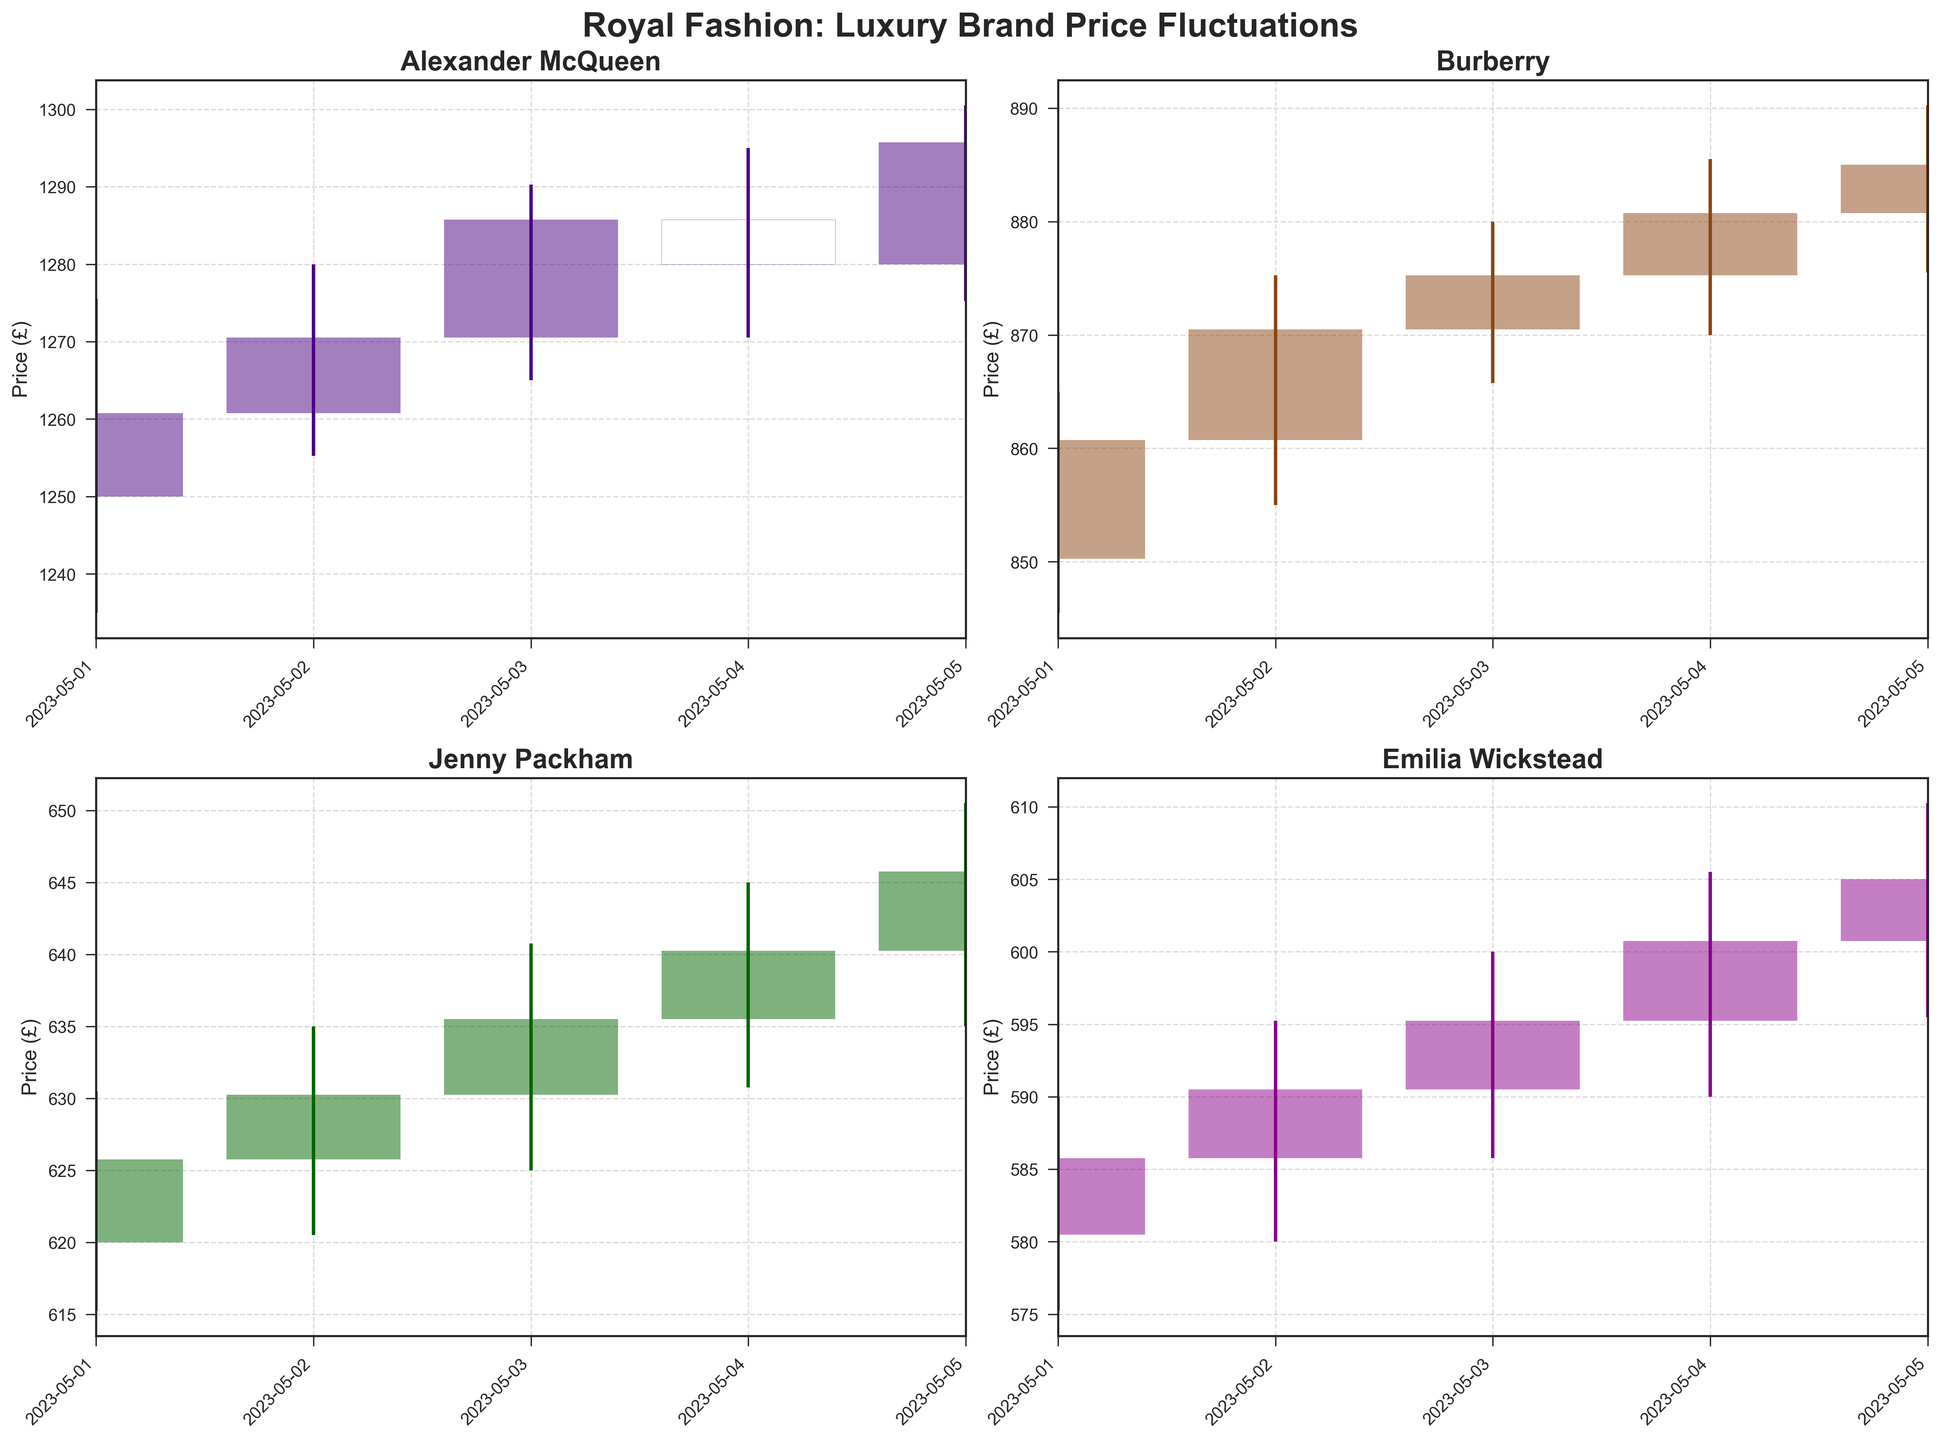What is the highest closing price for Alexander McQueen during the time period shown? The plot for Alexander McQueen displays daily price data, including closing prices. Identify the highest point on the closing price axis for Alexander McQueen.
Answer: 1295.75 Which brand had the lowest closing price on May 1, 2023? Look at the closing prices for each brand on May 1 in their respective subplots. Compare these values to determine the lowest one.
Answer: Emilia Wickstead How do the closing prices of Burberry and Jenny Packham compare on May 3, 2023? Check the Burberry and Jenny Packham subplots for May 3. Identify and compare the closing prices.
Answer: Burberry closed higher What is the average closing price of Emilia Wickstead over the five days shown? Sum the closing prices of Emilia Wickstead (585.75, 590.50, 595.25, 600.75, 605.00) and divide by the number of days (5).
Answer: 595.45 Which brand showed the most consistent range between their low and high prices? Examine the length of the vertical lines (high minus low) for each brand. Determine which brand has the smallest variation in these ranges.
Answer: Jenny Packham On which day did Jenny Packham experience the largest fluctuation between high and low prices? Look at the Jenny Packham subplot. Find the day with the most extended vertical line (largest difference between high and low).
Answer: May 5, 2023 Which brand had the highest opening price on May 2, 2023? Look at the opening prices for each brand on May 2. Compare them to determine the highest.
Answer: Alexander McQueen What was the general trend of Alexander McQueen's closing prices over the time period? Observe the sequence of closing prices in Alexander McQueen's subplot. Describe the overall direction they moved.
Answer: Upward trend Compare the closing price trends of Burberry and Emilia Wickstead. Which brand had a more significant increase? Examine the closing prices for both brands from May 1 to May 5. Calculate the difference between the starting and ending prices for both brands and compare.
Answer: Burberry On which day did any brand experience a closing price lower than its opening price? Check the subplots for each brand. Identify any day where the closing price (bottom of the upper horizontal line) is below the opening price (top of the lower horizontal line).
Answer: None 